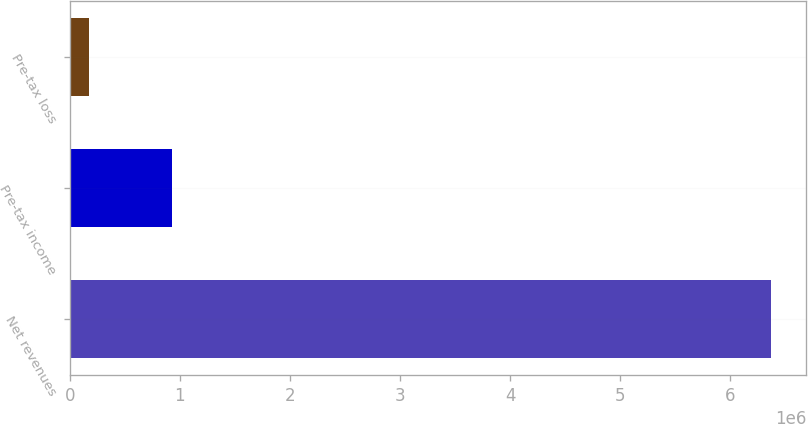<chart> <loc_0><loc_0><loc_500><loc_500><bar_chart><fcel>Net revenues<fcel>Pre-tax income<fcel>Pre-tax loss<nl><fcel>6.3711e+06<fcel>925346<fcel>169879<nl></chart> 